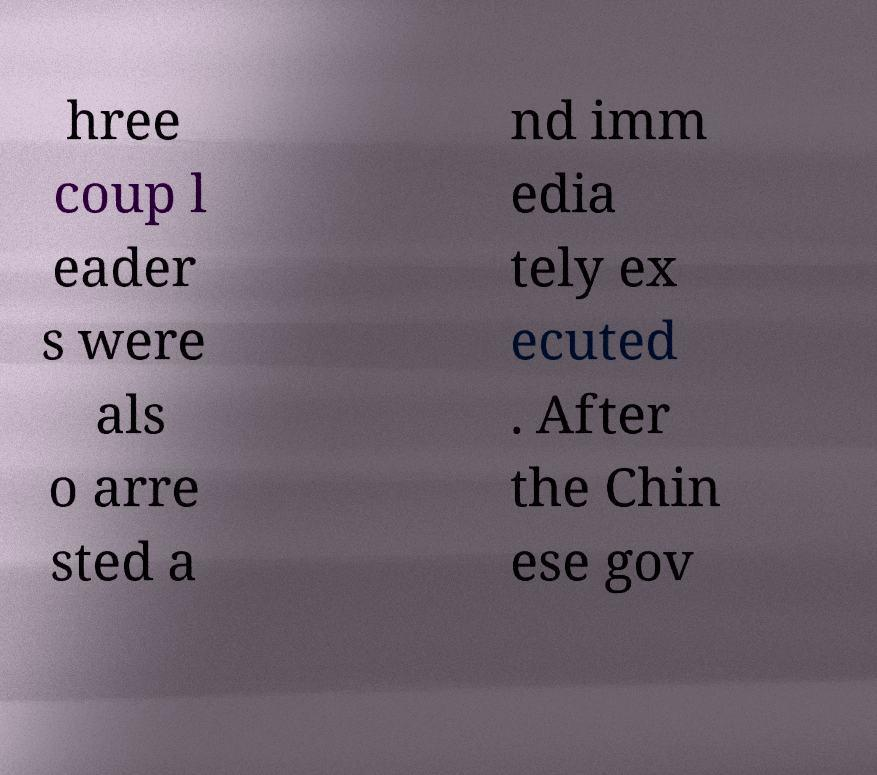For documentation purposes, I need the text within this image transcribed. Could you provide that? hree coup l eader s were als o arre sted a nd imm edia tely ex ecuted . After the Chin ese gov 